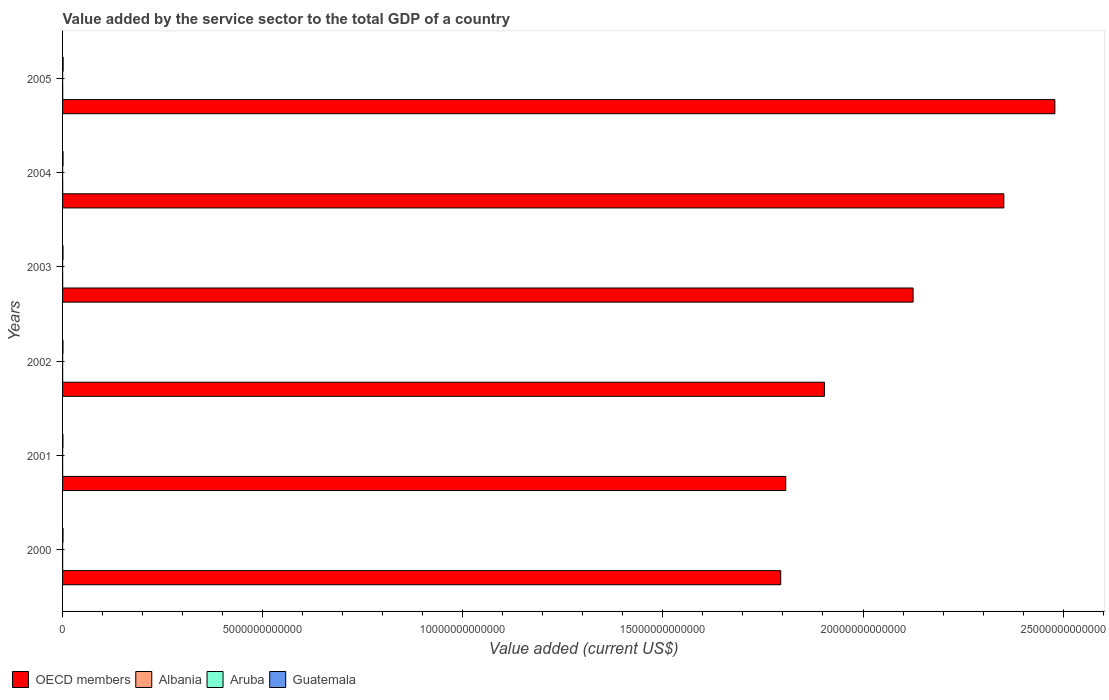Are the number of bars on each tick of the Y-axis equal?
Your answer should be very brief. Yes. What is the value added by the service sector to the total GDP in Guatemala in 2000?
Make the answer very short. 1.11e+1. Across all years, what is the maximum value added by the service sector to the total GDP in Albania?
Keep it short and to the point. 3.83e+09. Across all years, what is the minimum value added by the service sector to the total GDP in Guatemala?
Keep it short and to the point. 9.65e+09. In which year was the value added by the service sector to the total GDP in OECD members minimum?
Provide a short and direct response. 2000. What is the total value added by the service sector to the total GDP in Aruba in the graph?
Provide a succinct answer. 9.22e+09. What is the difference between the value added by the service sector to the total GDP in Albania in 2001 and that in 2002?
Your answer should be compact. -1.34e+08. What is the difference between the value added by the service sector to the total GDP in OECD members in 2004 and the value added by the service sector to the total GDP in Guatemala in 2005?
Offer a very short reply. 2.35e+13. What is the average value added by the service sector to the total GDP in Guatemala per year?
Keep it short and to the point. 1.16e+1. In the year 2001, what is the difference between the value added by the service sector to the total GDP in OECD members and value added by the service sector to the total GDP in Aruba?
Your response must be concise. 1.81e+13. In how many years, is the value added by the service sector to the total GDP in OECD members greater than 7000000000000 US$?
Keep it short and to the point. 6. What is the ratio of the value added by the service sector to the total GDP in Aruba in 2001 to that in 2005?
Your answer should be very brief. 0.87. Is the value added by the service sector to the total GDP in Aruba in 2004 less than that in 2005?
Keep it short and to the point. Yes. What is the difference between the highest and the second highest value added by the service sector to the total GDP in Aruba?
Offer a very short reply. 4.78e+07. What is the difference between the highest and the lowest value added by the service sector to the total GDP in Aruba?
Ensure brevity in your answer.  2.64e+08. In how many years, is the value added by the service sector to the total GDP in Albania greater than the average value added by the service sector to the total GDP in Albania taken over all years?
Your answer should be compact. 2. Is it the case that in every year, the sum of the value added by the service sector to the total GDP in Guatemala and value added by the service sector to the total GDP in Albania is greater than the sum of value added by the service sector to the total GDP in Aruba and value added by the service sector to the total GDP in OECD members?
Give a very brief answer. Yes. What does the 3rd bar from the top in 2002 represents?
Ensure brevity in your answer.  Albania. What does the 3rd bar from the bottom in 2005 represents?
Provide a short and direct response. Aruba. Is it the case that in every year, the sum of the value added by the service sector to the total GDP in Albania and value added by the service sector to the total GDP in Guatemala is greater than the value added by the service sector to the total GDP in OECD members?
Provide a succinct answer. No. How many bars are there?
Your response must be concise. 24. Are all the bars in the graph horizontal?
Keep it short and to the point. Yes. How many years are there in the graph?
Offer a very short reply. 6. What is the difference between two consecutive major ticks on the X-axis?
Offer a very short reply. 5.00e+12. Does the graph contain any zero values?
Your response must be concise. No. How many legend labels are there?
Give a very brief answer. 4. What is the title of the graph?
Keep it short and to the point. Value added by the service sector to the total GDP of a country. What is the label or title of the X-axis?
Your response must be concise. Value added (current US$). What is the Value added (current US$) of OECD members in 2000?
Offer a terse response. 1.79e+13. What is the Value added (current US$) of Albania in 2000?
Ensure brevity in your answer.  1.83e+09. What is the Value added (current US$) in Aruba in 2000?
Give a very brief answer. 1.42e+09. What is the Value added (current US$) in Guatemala in 2000?
Provide a short and direct response. 1.11e+1. What is the Value added (current US$) of OECD members in 2001?
Ensure brevity in your answer.  1.81e+13. What is the Value added (current US$) in Albania in 2001?
Ensure brevity in your answer.  2.09e+09. What is the Value added (current US$) in Aruba in 2001?
Offer a very short reply. 1.46e+09. What is the Value added (current US$) in Guatemala in 2001?
Provide a short and direct response. 9.65e+09. What is the Value added (current US$) of OECD members in 2002?
Offer a terse response. 1.90e+13. What is the Value added (current US$) of Albania in 2002?
Keep it short and to the point. 2.22e+09. What is the Value added (current US$) in Aruba in 2002?
Keep it short and to the point. 1.49e+09. What is the Value added (current US$) of Guatemala in 2002?
Make the answer very short. 1.06e+1. What is the Value added (current US$) in OECD members in 2003?
Make the answer very short. 2.13e+13. What is the Value added (current US$) in Albania in 2003?
Offer a very short reply. 2.66e+09. What is the Value added (current US$) in Aruba in 2003?
Offer a terse response. 1.51e+09. What is the Value added (current US$) in Guatemala in 2003?
Offer a very short reply. 1.14e+1. What is the Value added (current US$) of OECD members in 2004?
Make the answer very short. 2.35e+13. What is the Value added (current US$) in Albania in 2004?
Keep it short and to the point. 3.38e+09. What is the Value added (current US$) of Aruba in 2004?
Your answer should be very brief. 1.64e+09. What is the Value added (current US$) in Guatemala in 2004?
Offer a very short reply. 1.24e+1. What is the Value added (current US$) in OECD members in 2005?
Ensure brevity in your answer.  2.48e+13. What is the Value added (current US$) of Albania in 2005?
Your response must be concise. 3.83e+09. What is the Value added (current US$) in Aruba in 2005?
Keep it short and to the point. 1.69e+09. What is the Value added (current US$) of Guatemala in 2005?
Ensure brevity in your answer.  1.44e+1. Across all years, what is the maximum Value added (current US$) of OECD members?
Give a very brief answer. 2.48e+13. Across all years, what is the maximum Value added (current US$) of Albania?
Provide a short and direct response. 3.83e+09. Across all years, what is the maximum Value added (current US$) in Aruba?
Your answer should be very brief. 1.69e+09. Across all years, what is the maximum Value added (current US$) of Guatemala?
Provide a short and direct response. 1.44e+1. Across all years, what is the minimum Value added (current US$) of OECD members?
Keep it short and to the point. 1.79e+13. Across all years, what is the minimum Value added (current US$) in Albania?
Your response must be concise. 1.83e+09. Across all years, what is the minimum Value added (current US$) of Aruba?
Your answer should be very brief. 1.42e+09. Across all years, what is the minimum Value added (current US$) in Guatemala?
Offer a terse response. 9.65e+09. What is the total Value added (current US$) of OECD members in the graph?
Your answer should be compact. 1.25e+14. What is the total Value added (current US$) of Albania in the graph?
Give a very brief answer. 1.60e+1. What is the total Value added (current US$) of Aruba in the graph?
Keep it short and to the point. 9.22e+09. What is the total Value added (current US$) of Guatemala in the graph?
Give a very brief answer. 6.96e+1. What is the difference between the Value added (current US$) in OECD members in 2000 and that in 2001?
Your response must be concise. -1.26e+11. What is the difference between the Value added (current US$) of Albania in 2000 and that in 2001?
Offer a terse response. -2.56e+08. What is the difference between the Value added (current US$) in Aruba in 2000 and that in 2001?
Ensure brevity in your answer.  -3.76e+07. What is the difference between the Value added (current US$) in Guatemala in 2000 and that in 2001?
Provide a succinct answer. 1.42e+09. What is the difference between the Value added (current US$) of OECD members in 2000 and that in 2002?
Your answer should be compact. -1.09e+12. What is the difference between the Value added (current US$) of Albania in 2000 and that in 2002?
Offer a terse response. -3.90e+08. What is the difference between the Value added (current US$) in Aruba in 2000 and that in 2002?
Offer a very short reply. -6.73e+07. What is the difference between the Value added (current US$) of Guatemala in 2000 and that in 2002?
Keep it short and to the point. 4.34e+08. What is the difference between the Value added (current US$) in OECD members in 2000 and that in 2003?
Offer a terse response. -3.31e+12. What is the difference between the Value added (current US$) of Albania in 2000 and that in 2003?
Your answer should be very brief. -8.31e+08. What is the difference between the Value added (current US$) of Aruba in 2000 and that in 2003?
Give a very brief answer. -8.96e+07. What is the difference between the Value added (current US$) of Guatemala in 2000 and that in 2003?
Give a very brief answer. -2.92e+08. What is the difference between the Value added (current US$) in OECD members in 2000 and that in 2004?
Your answer should be very brief. -5.58e+12. What is the difference between the Value added (current US$) of Albania in 2000 and that in 2004?
Your answer should be compact. -1.55e+09. What is the difference between the Value added (current US$) of Aruba in 2000 and that in 2004?
Keep it short and to the point. -2.16e+08. What is the difference between the Value added (current US$) in Guatemala in 2000 and that in 2004?
Offer a terse response. -1.34e+09. What is the difference between the Value added (current US$) in OECD members in 2000 and that in 2005?
Your answer should be compact. -6.85e+12. What is the difference between the Value added (current US$) in Albania in 2000 and that in 2005?
Provide a succinct answer. -2.00e+09. What is the difference between the Value added (current US$) in Aruba in 2000 and that in 2005?
Provide a short and direct response. -2.64e+08. What is the difference between the Value added (current US$) of Guatemala in 2000 and that in 2005?
Your answer should be very brief. -3.37e+09. What is the difference between the Value added (current US$) of OECD members in 2001 and that in 2002?
Your response must be concise. -9.65e+11. What is the difference between the Value added (current US$) of Albania in 2001 and that in 2002?
Offer a terse response. -1.34e+08. What is the difference between the Value added (current US$) of Aruba in 2001 and that in 2002?
Your answer should be very brief. -2.96e+07. What is the difference between the Value added (current US$) in Guatemala in 2001 and that in 2002?
Offer a very short reply. -9.88e+08. What is the difference between the Value added (current US$) in OECD members in 2001 and that in 2003?
Provide a short and direct response. -3.18e+12. What is the difference between the Value added (current US$) of Albania in 2001 and that in 2003?
Your answer should be very brief. -5.75e+08. What is the difference between the Value added (current US$) of Aruba in 2001 and that in 2003?
Offer a very short reply. -5.20e+07. What is the difference between the Value added (current US$) of Guatemala in 2001 and that in 2003?
Keep it short and to the point. -1.71e+09. What is the difference between the Value added (current US$) of OECD members in 2001 and that in 2004?
Make the answer very short. -5.45e+12. What is the difference between the Value added (current US$) of Albania in 2001 and that in 2004?
Your answer should be very brief. -1.29e+09. What is the difference between the Value added (current US$) in Aruba in 2001 and that in 2004?
Provide a succinct answer. -1.78e+08. What is the difference between the Value added (current US$) of Guatemala in 2001 and that in 2004?
Your answer should be very brief. -2.77e+09. What is the difference between the Value added (current US$) in OECD members in 2001 and that in 2005?
Provide a short and direct response. -6.72e+12. What is the difference between the Value added (current US$) in Albania in 2001 and that in 2005?
Give a very brief answer. -1.74e+09. What is the difference between the Value added (current US$) in Aruba in 2001 and that in 2005?
Make the answer very short. -2.26e+08. What is the difference between the Value added (current US$) in Guatemala in 2001 and that in 2005?
Offer a very short reply. -4.79e+09. What is the difference between the Value added (current US$) of OECD members in 2002 and that in 2003?
Give a very brief answer. -2.22e+12. What is the difference between the Value added (current US$) in Albania in 2002 and that in 2003?
Give a very brief answer. -4.41e+08. What is the difference between the Value added (current US$) of Aruba in 2002 and that in 2003?
Your response must be concise. -2.23e+07. What is the difference between the Value added (current US$) of Guatemala in 2002 and that in 2003?
Provide a succinct answer. -7.26e+08. What is the difference between the Value added (current US$) of OECD members in 2002 and that in 2004?
Your response must be concise. -4.48e+12. What is the difference between the Value added (current US$) of Albania in 2002 and that in 2004?
Make the answer very short. -1.16e+09. What is the difference between the Value added (current US$) of Aruba in 2002 and that in 2004?
Provide a succinct answer. -1.49e+08. What is the difference between the Value added (current US$) in Guatemala in 2002 and that in 2004?
Keep it short and to the point. -1.78e+09. What is the difference between the Value added (current US$) of OECD members in 2002 and that in 2005?
Offer a very short reply. -5.76e+12. What is the difference between the Value added (current US$) of Albania in 2002 and that in 2005?
Give a very brief answer. -1.61e+09. What is the difference between the Value added (current US$) of Aruba in 2002 and that in 2005?
Provide a succinct answer. -1.97e+08. What is the difference between the Value added (current US$) in Guatemala in 2002 and that in 2005?
Provide a short and direct response. -3.80e+09. What is the difference between the Value added (current US$) of OECD members in 2003 and that in 2004?
Make the answer very short. -2.27e+12. What is the difference between the Value added (current US$) of Albania in 2003 and that in 2004?
Keep it short and to the point. -7.17e+08. What is the difference between the Value added (current US$) in Aruba in 2003 and that in 2004?
Offer a terse response. -1.26e+08. What is the difference between the Value added (current US$) in Guatemala in 2003 and that in 2004?
Ensure brevity in your answer.  -1.05e+09. What is the difference between the Value added (current US$) of OECD members in 2003 and that in 2005?
Keep it short and to the point. -3.54e+12. What is the difference between the Value added (current US$) of Albania in 2003 and that in 2005?
Offer a terse response. -1.17e+09. What is the difference between the Value added (current US$) of Aruba in 2003 and that in 2005?
Your response must be concise. -1.74e+08. What is the difference between the Value added (current US$) in Guatemala in 2003 and that in 2005?
Make the answer very short. -3.07e+09. What is the difference between the Value added (current US$) in OECD members in 2004 and that in 2005?
Ensure brevity in your answer.  -1.28e+12. What is the difference between the Value added (current US$) of Albania in 2004 and that in 2005?
Provide a short and direct response. -4.50e+08. What is the difference between the Value added (current US$) of Aruba in 2004 and that in 2005?
Provide a succinct answer. -4.78e+07. What is the difference between the Value added (current US$) in Guatemala in 2004 and that in 2005?
Ensure brevity in your answer.  -2.02e+09. What is the difference between the Value added (current US$) in OECD members in 2000 and the Value added (current US$) in Albania in 2001?
Make the answer very short. 1.79e+13. What is the difference between the Value added (current US$) of OECD members in 2000 and the Value added (current US$) of Aruba in 2001?
Keep it short and to the point. 1.79e+13. What is the difference between the Value added (current US$) of OECD members in 2000 and the Value added (current US$) of Guatemala in 2001?
Your answer should be compact. 1.79e+13. What is the difference between the Value added (current US$) in Albania in 2000 and the Value added (current US$) in Aruba in 2001?
Offer a very short reply. 3.68e+08. What is the difference between the Value added (current US$) of Albania in 2000 and the Value added (current US$) of Guatemala in 2001?
Keep it short and to the point. -7.82e+09. What is the difference between the Value added (current US$) in Aruba in 2000 and the Value added (current US$) in Guatemala in 2001?
Offer a terse response. -8.22e+09. What is the difference between the Value added (current US$) of OECD members in 2000 and the Value added (current US$) of Albania in 2002?
Your response must be concise. 1.79e+13. What is the difference between the Value added (current US$) in OECD members in 2000 and the Value added (current US$) in Aruba in 2002?
Offer a very short reply. 1.79e+13. What is the difference between the Value added (current US$) in OECD members in 2000 and the Value added (current US$) in Guatemala in 2002?
Provide a short and direct response. 1.79e+13. What is the difference between the Value added (current US$) of Albania in 2000 and the Value added (current US$) of Aruba in 2002?
Keep it short and to the point. 3.38e+08. What is the difference between the Value added (current US$) in Albania in 2000 and the Value added (current US$) in Guatemala in 2002?
Make the answer very short. -8.81e+09. What is the difference between the Value added (current US$) in Aruba in 2000 and the Value added (current US$) in Guatemala in 2002?
Keep it short and to the point. -9.21e+09. What is the difference between the Value added (current US$) in OECD members in 2000 and the Value added (current US$) in Albania in 2003?
Keep it short and to the point. 1.79e+13. What is the difference between the Value added (current US$) of OECD members in 2000 and the Value added (current US$) of Aruba in 2003?
Offer a terse response. 1.79e+13. What is the difference between the Value added (current US$) of OECD members in 2000 and the Value added (current US$) of Guatemala in 2003?
Ensure brevity in your answer.  1.79e+13. What is the difference between the Value added (current US$) of Albania in 2000 and the Value added (current US$) of Aruba in 2003?
Make the answer very short. 3.16e+08. What is the difference between the Value added (current US$) of Albania in 2000 and the Value added (current US$) of Guatemala in 2003?
Your response must be concise. -9.53e+09. What is the difference between the Value added (current US$) of Aruba in 2000 and the Value added (current US$) of Guatemala in 2003?
Ensure brevity in your answer.  -9.94e+09. What is the difference between the Value added (current US$) of OECD members in 2000 and the Value added (current US$) of Albania in 2004?
Offer a very short reply. 1.79e+13. What is the difference between the Value added (current US$) of OECD members in 2000 and the Value added (current US$) of Aruba in 2004?
Your response must be concise. 1.79e+13. What is the difference between the Value added (current US$) in OECD members in 2000 and the Value added (current US$) in Guatemala in 2004?
Your response must be concise. 1.79e+13. What is the difference between the Value added (current US$) of Albania in 2000 and the Value added (current US$) of Aruba in 2004?
Your answer should be compact. 1.89e+08. What is the difference between the Value added (current US$) of Albania in 2000 and the Value added (current US$) of Guatemala in 2004?
Give a very brief answer. -1.06e+1. What is the difference between the Value added (current US$) in Aruba in 2000 and the Value added (current US$) in Guatemala in 2004?
Provide a short and direct response. -1.10e+1. What is the difference between the Value added (current US$) of OECD members in 2000 and the Value added (current US$) of Albania in 2005?
Offer a terse response. 1.79e+13. What is the difference between the Value added (current US$) of OECD members in 2000 and the Value added (current US$) of Aruba in 2005?
Offer a terse response. 1.79e+13. What is the difference between the Value added (current US$) in OECD members in 2000 and the Value added (current US$) in Guatemala in 2005?
Your answer should be compact. 1.79e+13. What is the difference between the Value added (current US$) in Albania in 2000 and the Value added (current US$) in Aruba in 2005?
Ensure brevity in your answer.  1.42e+08. What is the difference between the Value added (current US$) of Albania in 2000 and the Value added (current US$) of Guatemala in 2005?
Provide a succinct answer. -1.26e+1. What is the difference between the Value added (current US$) of Aruba in 2000 and the Value added (current US$) of Guatemala in 2005?
Your answer should be compact. -1.30e+1. What is the difference between the Value added (current US$) in OECD members in 2001 and the Value added (current US$) in Albania in 2002?
Give a very brief answer. 1.81e+13. What is the difference between the Value added (current US$) in OECD members in 2001 and the Value added (current US$) in Aruba in 2002?
Offer a very short reply. 1.81e+13. What is the difference between the Value added (current US$) in OECD members in 2001 and the Value added (current US$) in Guatemala in 2002?
Your answer should be compact. 1.81e+13. What is the difference between the Value added (current US$) of Albania in 2001 and the Value added (current US$) of Aruba in 2002?
Your response must be concise. 5.94e+08. What is the difference between the Value added (current US$) in Albania in 2001 and the Value added (current US$) in Guatemala in 2002?
Give a very brief answer. -8.55e+09. What is the difference between the Value added (current US$) of Aruba in 2001 and the Value added (current US$) of Guatemala in 2002?
Your answer should be very brief. -9.17e+09. What is the difference between the Value added (current US$) of OECD members in 2001 and the Value added (current US$) of Albania in 2003?
Your response must be concise. 1.81e+13. What is the difference between the Value added (current US$) in OECD members in 2001 and the Value added (current US$) in Aruba in 2003?
Make the answer very short. 1.81e+13. What is the difference between the Value added (current US$) in OECD members in 2001 and the Value added (current US$) in Guatemala in 2003?
Ensure brevity in your answer.  1.81e+13. What is the difference between the Value added (current US$) of Albania in 2001 and the Value added (current US$) of Aruba in 2003?
Provide a short and direct response. 5.72e+08. What is the difference between the Value added (current US$) of Albania in 2001 and the Value added (current US$) of Guatemala in 2003?
Your response must be concise. -9.28e+09. What is the difference between the Value added (current US$) in Aruba in 2001 and the Value added (current US$) in Guatemala in 2003?
Give a very brief answer. -9.90e+09. What is the difference between the Value added (current US$) in OECD members in 2001 and the Value added (current US$) in Albania in 2004?
Provide a short and direct response. 1.81e+13. What is the difference between the Value added (current US$) in OECD members in 2001 and the Value added (current US$) in Aruba in 2004?
Provide a succinct answer. 1.81e+13. What is the difference between the Value added (current US$) of OECD members in 2001 and the Value added (current US$) of Guatemala in 2004?
Your answer should be compact. 1.81e+13. What is the difference between the Value added (current US$) in Albania in 2001 and the Value added (current US$) in Aruba in 2004?
Offer a very short reply. 4.45e+08. What is the difference between the Value added (current US$) of Albania in 2001 and the Value added (current US$) of Guatemala in 2004?
Keep it short and to the point. -1.03e+1. What is the difference between the Value added (current US$) of Aruba in 2001 and the Value added (current US$) of Guatemala in 2004?
Provide a succinct answer. -1.10e+1. What is the difference between the Value added (current US$) of OECD members in 2001 and the Value added (current US$) of Albania in 2005?
Your answer should be very brief. 1.81e+13. What is the difference between the Value added (current US$) of OECD members in 2001 and the Value added (current US$) of Aruba in 2005?
Offer a terse response. 1.81e+13. What is the difference between the Value added (current US$) in OECD members in 2001 and the Value added (current US$) in Guatemala in 2005?
Provide a succinct answer. 1.81e+13. What is the difference between the Value added (current US$) of Albania in 2001 and the Value added (current US$) of Aruba in 2005?
Offer a very short reply. 3.97e+08. What is the difference between the Value added (current US$) in Albania in 2001 and the Value added (current US$) in Guatemala in 2005?
Keep it short and to the point. -1.24e+1. What is the difference between the Value added (current US$) in Aruba in 2001 and the Value added (current US$) in Guatemala in 2005?
Provide a succinct answer. -1.30e+1. What is the difference between the Value added (current US$) of OECD members in 2002 and the Value added (current US$) of Albania in 2003?
Offer a terse response. 1.90e+13. What is the difference between the Value added (current US$) in OECD members in 2002 and the Value added (current US$) in Aruba in 2003?
Provide a short and direct response. 1.90e+13. What is the difference between the Value added (current US$) of OECD members in 2002 and the Value added (current US$) of Guatemala in 2003?
Offer a very short reply. 1.90e+13. What is the difference between the Value added (current US$) in Albania in 2002 and the Value added (current US$) in Aruba in 2003?
Ensure brevity in your answer.  7.06e+08. What is the difference between the Value added (current US$) in Albania in 2002 and the Value added (current US$) in Guatemala in 2003?
Keep it short and to the point. -9.14e+09. What is the difference between the Value added (current US$) in Aruba in 2002 and the Value added (current US$) in Guatemala in 2003?
Give a very brief answer. -9.87e+09. What is the difference between the Value added (current US$) in OECD members in 2002 and the Value added (current US$) in Albania in 2004?
Offer a very short reply. 1.90e+13. What is the difference between the Value added (current US$) of OECD members in 2002 and the Value added (current US$) of Aruba in 2004?
Offer a very short reply. 1.90e+13. What is the difference between the Value added (current US$) of OECD members in 2002 and the Value added (current US$) of Guatemala in 2004?
Give a very brief answer. 1.90e+13. What is the difference between the Value added (current US$) of Albania in 2002 and the Value added (current US$) of Aruba in 2004?
Offer a terse response. 5.79e+08. What is the difference between the Value added (current US$) in Albania in 2002 and the Value added (current US$) in Guatemala in 2004?
Ensure brevity in your answer.  -1.02e+1. What is the difference between the Value added (current US$) in Aruba in 2002 and the Value added (current US$) in Guatemala in 2004?
Provide a short and direct response. -1.09e+1. What is the difference between the Value added (current US$) of OECD members in 2002 and the Value added (current US$) of Albania in 2005?
Your answer should be very brief. 1.90e+13. What is the difference between the Value added (current US$) of OECD members in 2002 and the Value added (current US$) of Aruba in 2005?
Offer a terse response. 1.90e+13. What is the difference between the Value added (current US$) in OECD members in 2002 and the Value added (current US$) in Guatemala in 2005?
Offer a terse response. 1.90e+13. What is the difference between the Value added (current US$) in Albania in 2002 and the Value added (current US$) in Aruba in 2005?
Offer a very short reply. 5.32e+08. What is the difference between the Value added (current US$) in Albania in 2002 and the Value added (current US$) in Guatemala in 2005?
Your answer should be very brief. -1.22e+1. What is the difference between the Value added (current US$) of Aruba in 2002 and the Value added (current US$) of Guatemala in 2005?
Keep it short and to the point. -1.29e+1. What is the difference between the Value added (current US$) in OECD members in 2003 and the Value added (current US$) in Albania in 2004?
Offer a terse response. 2.12e+13. What is the difference between the Value added (current US$) of OECD members in 2003 and the Value added (current US$) of Aruba in 2004?
Offer a terse response. 2.12e+13. What is the difference between the Value added (current US$) of OECD members in 2003 and the Value added (current US$) of Guatemala in 2004?
Your answer should be very brief. 2.12e+13. What is the difference between the Value added (current US$) in Albania in 2003 and the Value added (current US$) in Aruba in 2004?
Offer a terse response. 1.02e+09. What is the difference between the Value added (current US$) of Albania in 2003 and the Value added (current US$) of Guatemala in 2004?
Your response must be concise. -9.75e+09. What is the difference between the Value added (current US$) of Aruba in 2003 and the Value added (current US$) of Guatemala in 2004?
Keep it short and to the point. -1.09e+1. What is the difference between the Value added (current US$) of OECD members in 2003 and the Value added (current US$) of Albania in 2005?
Your answer should be very brief. 2.12e+13. What is the difference between the Value added (current US$) of OECD members in 2003 and the Value added (current US$) of Aruba in 2005?
Your response must be concise. 2.12e+13. What is the difference between the Value added (current US$) in OECD members in 2003 and the Value added (current US$) in Guatemala in 2005?
Give a very brief answer. 2.12e+13. What is the difference between the Value added (current US$) of Albania in 2003 and the Value added (current US$) of Aruba in 2005?
Provide a short and direct response. 9.73e+08. What is the difference between the Value added (current US$) in Albania in 2003 and the Value added (current US$) in Guatemala in 2005?
Offer a terse response. -1.18e+1. What is the difference between the Value added (current US$) of Aruba in 2003 and the Value added (current US$) of Guatemala in 2005?
Offer a terse response. -1.29e+1. What is the difference between the Value added (current US$) in OECD members in 2004 and the Value added (current US$) in Albania in 2005?
Your answer should be compact. 2.35e+13. What is the difference between the Value added (current US$) in OECD members in 2004 and the Value added (current US$) in Aruba in 2005?
Provide a short and direct response. 2.35e+13. What is the difference between the Value added (current US$) in OECD members in 2004 and the Value added (current US$) in Guatemala in 2005?
Provide a succinct answer. 2.35e+13. What is the difference between the Value added (current US$) in Albania in 2004 and the Value added (current US$) in Aruba in 2005?
Your response must be concise. 1.69e+09. What is the difference between the Value added (current US$) of Albania in 2004 and the Value added (current US$) of Guatemala in 2005?
Give a very brief answer. -1.11e+1. What is the difference between the Value added (current US$) of Aruba in 2004 and the Value added (current US$) of Guatemala in 2005?
Keep it short and to the point. -1.28e+1. What is the average Value added (current US$) in OECD members per year?
Offer a very short reply. 2.08e+13. What is the average Value added (current US$) of Albania per year?
Ensure brevity in your answer.  2.67e+09. What is the average Value added (current US$) of Aruba per year?
Offer a terse response. 1.54e+09. What is the average Value added (current US$) of Guatemala per year?
Provide a succinct answer. 1.16e+1. In the year 2000, what is the difference between the Value added (current US$) in OECD members and Value added (current US$) in Albania?
Your response must be concise. 1.79e+13. In the year 2000, what is the difference between the Value added (current US$) in OECD members and Value added (current US$) in Aruba?
Keep it short and to the point. 1.79e+13. In the year 2000, what is the difference between the Value added (current US$) of OECD members and Value added (current US$) of Guatemala?
Make the answer very short. 1.79e+13. In the year 2000, what is the difference between the Value added (current US$) in Albania and Value added (current US$) in Aruba?
Offer a very short reply. 4.05e+08. In the year 2000, what is the difference between the Value added (current US$) in Albania and Value added (current US$) in Guatemala?
Offer a very short reply. -9.24e+09. In the year 2000, what is the difference between the Value added (current US$) of Aruba and Value added (current US$) of Guatemala?
Provide a short and direct response. -9.65e+09. In the year 2001, what is the difference between the Value added (current US$) of OECD members and Value added (current US$) of Albania?
Offer a terse response. 1.81e+13. In the year 2001, what is the difference between the Value added (current US$) in OECD members and Value added (current US$) in Aruba?
Ensure brevity in your answer.  1.81e+13. In the year 2001, what is the difference between the Value added (current US$) of OECD members and Value added (current US$) of Guatemala?
Provide a short and direct response. 1.81e+13. In the year 2001, what is the difference between the Value added (current US$) in Albania and Value added (current US$) in Aruba?
Make the answer very short. 6.24e+08. In the year 2001, what is the difference between the Value added (current US$) of Albania and Value added (current US$) of Guatemala?
Provide a succinct answer. -7.56e+09. In the year 2001, what is the difference between the Value added (current US$) of Aruba and Value added (current US$) of Guatemala?
Offer a terse response. -8.19e+09. In the year 2002, what is the difference between the Value added (current US$) of OECD members and Value added (current US$) of Albania?
Keep it short and to the point. 1.90e+13. In the year 2002, what is the difference between the Value added (current US$) in OECD members and Value added (current US$) in Aruba?
Provide a short and direct response. 1.90e+13. In the year 2002, what is the difference between the Value added (current US$) in OECD members and Value added (current US$) in Guatemala?
Your response must be concise. 1.90e+13. In the year 2002, what is the difference between the Value added (current US$) in Albania and Value added (current US$) in Aruba?
Provide a short and direct response. 7.28e+08. In the year 2002, what is the difference between the Value added (current US$) of Albania and Value added (current US$) of Guatemala?
Offer a terse response. -8.42e+09. In the year 2002, what is the difference between the Value added (current US$) in Aruba and Value added (current US$) in Guatemala?
Your answer should be compact. -9.14e+09. In the year 2003, what is the difference between the Value added (current US$) of OECD members and Value added (current US$) of Albania?
Provide a short and direct response. 2.12e+13. In the year 2003, what is the difference between the Value added (current US$) of OECD members and Value added (current US$) of Aruba?
Your answer should be compact. 2.12e+13. In the year 2003, what is the difference between the Value added (current US$) of OECD members and Value added (current US$) of Guatemala?
Provide a succinct answer. 2.12e+13. In the year 2003, what is the difference between the Value added (current US$) in Albania and Value added (current US$) in Aruba?
Offer a very short reply. 1.15e+09. In the year 2003, what is the difference between the Value added (current US$) in Albania and Value added (current US$) in Guatemala?
Offer a terse response. -8.70e+09. In the year 2003, what is the difference between the Value added (current US$) in Aruba and Value added (current US$) in Guatemala?
Give a very brief answer. -9.85e+09. In the year 2004, what is the difference between the Value added (current US$) of OECD members and Value added (current US$) of Albania?
Make the answer very short. 2.35e+13. In the year 2004, what is the difference between the Value added (current US$) in OECD members and Value added (current US$) in Aruba?
Ensure brevity in your answer.  2.35e+13. In the year 2004, what is the difference between the Value added (current US$) in OECD members and Value added (current US$) in Guatemala?
Your answer should be compact. 2.35e+13. In the year 2004, what is the difference between the Value added (current US$) in Albania and Value added (current US$) in Aruba?
Provide a succinct answer. 1.74e+09. In the year 2004, what is the difference between the Value added (current US$) in Albania and Value added (current US$) in Guatemala?
Keep it short and to the point. -9.04e+09. In the year 2004, what is the difference between the Value added (current US$) in Aruba and Value added (current US$) in Guatemala?
Your answer should be very brief. -1.08e+1. In the year 2005, what is the difference between the Value added (current US$) of OECD members and Value added (current US$) of Albania?
Ensure brevity in your answer.  2.48e+13. In the year 2005, what is the difference between the Value added (current US$) in OECD members and Value added (current US$) in Aruba?
Your response must be concise. 2.48e+13. In the year 2005, what is the difference between the Value added (current US$) of OECD members and Value added (current US$) of Guatemala?
Keep it short and to the point. 2.48e+13. In the year 2005, what is the difference between the Value added (current US$) of Albania and Value added (current US$) of Aruba?
Make the answer very short. 2.14e+09. In the year 2005, what is the difference between the Value added (current US$) of Albania and Value added (current US$) of Guatemala?
Your response must be concise. -1.06e+1. In the year 2005, what is the difference between the Value added (current US$) of Aruba and Value added (current US$) of Guatemala?
Make the answer very short. -1.27e+1. What is the ratio of the Value added (current US$) of OECD members in 2000 to that in 2001?
Offer a very short reply. 0.99. What is the ratio of the Value added (current US$) of Albania in 2000 to that in 2001?
Your answer should be compact. 0.88. What is the ratio of the Value added (current US$) in Aruba in 2000 to that in 2001?
Your answer should be very brief. 0.97. What is the ratio of the Value added (current US$) of Guatemala in 2000 to that in 2001?
Give a very brief answer. 1.15. What is the ratio of the Value added (current US$) of OECD members in 2000 to that in 2002?
Offer a very short reply. 0.94. What is the ratio of the Value added (current US$) in Albania in 2000 to that in 2002?
Ensure brevity in your answer.  0.82. What is the ratio of the Value added (current US$) of Aruba in 2000 to that in 2002?
Offer a terse response. 0.95. What is the ratio of the Value added (current US$) of Guatemala in 2000 to that in 2002?
Ensure brevity in your answer.  1.04. What is the ratio of the Value added (current US$) of OECD members in 2000 to that in 2003?
Provide a short and direct response. 0.84. What is the ratio of the Value added (current US$) of Albania in 2000 to that in 2003?
Provide a succinct answer. 0.69. What is the ratio of the Value added (current US$) in Aruba in 2000 to that in 2003?
Give a very brief answer. 0.94. What is the ratio of the Value added (current US$) of Guatemala in 2000 to that in 2003?
Provide a short and direct response. 0.97. What is the ratio of the Value added (current US$) in OECD members in 2000 to that in 2004?
Keep it short and to the point. 0.76. What is the ratio of the Value added (current US$) of Albania in 2000 to that in 2004?
Provide a succinct answer. 0.54. What is the ratio of the Value added (current US$) of Aruba in 2000 to that in 2004?
Keep it short and to the point. 0.87. What is the ratio of the Value added (current US$) of Guatemala in 2000 to that in 2004?
Your answer should be very brief. 0.89. What is the ratio of the Value added (current US$) in OECD members in 2000 to that in 2005?
Offer a terse response. 0.72. What is the ratio of the Value added (current US$) in Albania in 2000 to that in 2005?
Keep it short and to the point. 0.48. What is the ratio of the Value added (current US$) of Aruba in 2000 to that in 2005?
Your answer should be very brief. 0.84. What is the ratio of the Value added (current US$) of Guatemala in 2000 to that in 2005?
Give a very brief answer. 0.77. What is the ratio of the Value added (current US$) of OECD members in 2001 to that in 2002?
Make the answer very short. 0.95. What is the ratio of the Value added (current US$) in Albania in 2001 to that in 2002?
Your response must be concise. 0.94. What is the ratio of the Value added (current US$) of Aruba in 2001 to that in 2002?
Give a very brief answer. 0.98. What is the ratio of the Value added (current US$) in Guatemala in 2001 to that in 2002?
Offer a terse response. 0.91. What is the ratio of the Value added (current US$) of OECD members in 2001 to that in 2003?
Offer a very short reply. 0.85. What is the ratio of the Value added (current US$) of Albania in 2001 to that in 2003?
Provide a short and direct response. 0.78. What is the ratio of the Value added (current US$) in Aruba in 2001 to that in 2003?
Keep it short and to the point. 0.97. What is the ratio of the Value added (current US$) in Guatemala in 2001 to that in 2003?
Provide a succinct answer. 0.85. What is the ratio of the Value added (current US$) in OECD members in 2001 to that in 2004?
Your answer should be very brief. 0.77. What is the ratio of the Value added (current US$) in Albania in 2001 to that in 2004?
Your response must be concise. 0.62. What is the ratio of the Value added (current US$) of Aruba in 2001 to that in 2004?
Offer a terse response. 0.89. What is the ratio of the Value added (current US$) of Guatemala in 2001 to that in 2004?
Offer a very short reply. 0.78. What is the ratio of the Value added (current US$) of OECD members in 2001 to that in 2005?
Provide a short and direct response. 0.73. What is the ratio of the Value added (current US$) in Albania in 2001 to that in 2005?
Provide a succinct answer. 0.54. What is the ratio of the Value added (current US$) of Aruba in 2001 to that in 2005?
Provide a short and direct response. 0.87. What is the ratio of the Value added (current US$) of Guatemala in 2001 to that in 2005?
Ensure brevity in your answer.  0.67. What is the ratio of the Value added (current US$) in OECD members in 2002 to that in 2003?
Give a very brief answer. 0.9. What is the ratio of the Value added (current US$) of Albania in 2002 to that in 2003?
Provide a short and direct response. 0.83. What is the ratio of the Value added (current US$) in Guatemala in 2002 to that in 2003?
Offer a very short reply. 0.94. What is the ratio of the Value added (current US$) in OECD members in 2002 to that in 2004?
Provide a short and direct response. 0.81. What is the ratio of the Value added (current US$) in Albania in 2002 to that in 2004?
Ensure brevity in your answer.  0.66. What is the ratio of the Value added (current US$) of Aruba in 2002 to that in 2004?
Offer a terse response. 0.91. What is the ratio of the Value added (current US$) of Guatemala in 2002 to that in 2004?
Offer a terse response. 0.86. What is the ratio of the Value added (current US$) of OECD members in 2002 to that in 2005?
Give a very brief answer. 0.77. What is the ratio of the Value added (current US$) in Albania in 2002 to that in 2005?
Keep it short and to the point. 0.58. What is the ratio of the Value added (current US$) of Aruba in 2002 to that in 2005?
Offer a very short reply. 0.88. What is the ratio of the Value added (current US$) of Guatemala in 2002 to that in 2005?
Your answer should be very brief. 0.74. What is the ratio of the Value added (current US$) in OECD members in 2003 to that in 2004?
Give a very brief answer. 0.9. What is the ratio of the Value added (current US$) of Albania in 2003 to that in 2004?
Give a very brief answer. 0.79. What is the ratio of the Value added (current US$) in Aruba in 2003 to that in 2004?
Keep it short and to the point. 0.92. What is the ratio of the Value added (current US$) of Guatemala in 2003 to that in 2004?
Your response must be concise. 0.92. What is the ratio of the Value added (current US$) of Albania in 2003 to that in 2005?
Your answer should be very brief. 0.69. What is the ratio of the Value added (current US$) in Aruba in 2003 to that in 2005?
Offer a very short reply. 0.9. What is the ratio of the Value added (current US$) of Guatemala in 2003 to that in 2005?
Your answer should be very brief. 0.79. What is the ratio of the Value added (current US$) of OECD members in 2004 to that in 2005?
Ensure brevity in your answer.  0.95. What is the ratio of the Value added (current US$) in Albania in 2004 to that in 2005?
Offer a terse response. 0.88. What is the ratio of the Value added (current US$) of Aruba in 2004 to that in 2005?
Keep it short and to the point. 0.97. What is the ratio of the Value added (current US$) in Guatemala in 2004 to that in 2005?
Make the answer very short. 0.86. What is the difference between the highest and the second highest Value added (current US$) of OECD members?
Your answer should be compact. 1.28e+12. What is the difference between the highest and the second highest Value added (current US$) of Albania?
Keep it short and to the point. 4.50e+08. What is the difference between the highest and the second highest Value added (current US$) in Aruba?
Provide a succinct answer. 4.78e+07. What is the difference between the highest and the second highest Value added (current US$) in Guatemala?
Keep it short and to the point. 2.02e+09. What is the difference between the highest and the lowest Value added (current US$) in OECD members?
Keep it short and to the point. 6.85e+12. What is the difference between the highest and the lowest Value added (current US$) of Albania?
Keep it short and to the point. 2.00e+09. What is the difference between the highest and the lowest Value added (current US$) of Aruba?
Give a very brief answer. 2.64e+08. What is the difference between the highest and the lowest Value added (current US$) of Guatemala?
Ensure brevity in your answer.  4.79e+09. 